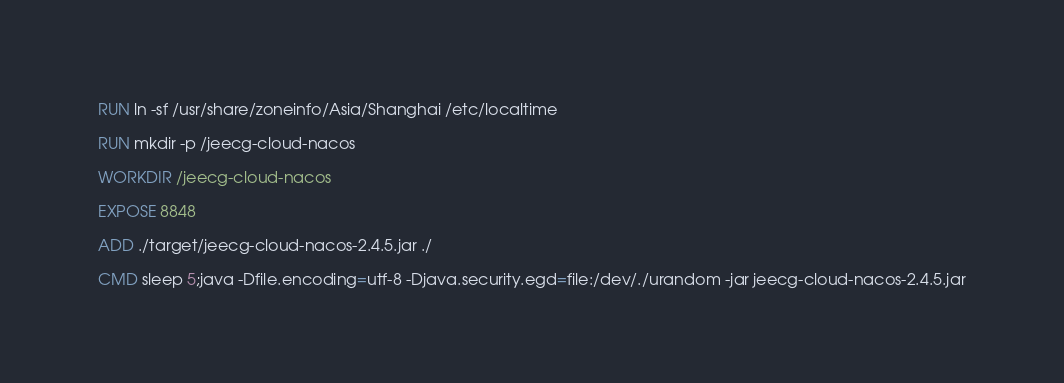<code> <loc_0><loc_0><loc_500><loc_500><_Dockerfile_>
RUN ln -sf /usr/share/zoneinfo/Asia/Shanghai /etc/localtime

RUN mkdir -p /jeecg-cloud-nacos

WORKDIR /jeecg-cloud-nacos

EXPOSE 8848

ADD ./target/jeecg-cloud-nacos-2.4.5.jar ./

CMD sleep 5;java -Dfile.encoding=utf-8 -Djava.security.egd=file:/dev/./urandom -jar jeecg-cloud-nacos-2.4.5.jar</code> 